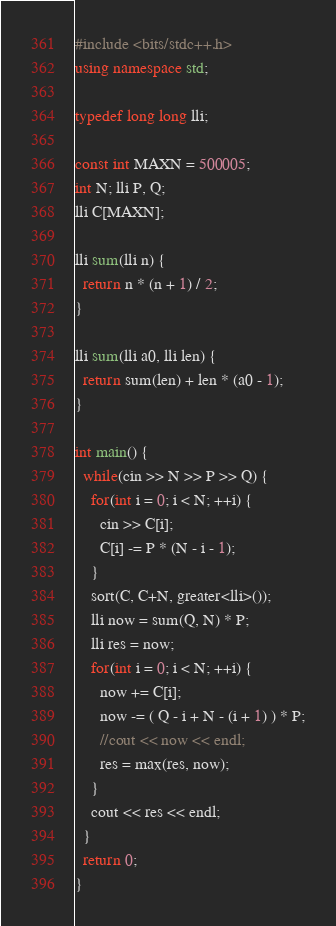Convert code to text. <code><loc_0><loc_0><loc_500><loc_500><_C++_>#include <bits/stdc++.h>
using namespace std;

typedef long long lli;

const int MAXN = 500005;
int N; lli P, Q;
lli C[MAXN];

lli sum(lli n) {
  return n * (n + 1) / 2;
}

lli sum(lli a0, lli len) {
  return sum(len) + len * (a0 - 1);
}

int main() {
  while(cin >> N >> P >> Q) {
    for(int i = 0; i < N; ++i) {
      cin >> C[i];
      C[i] -= P * (N - i - 1);
    }
    sort(C, C+N, greater<lli>());
    lli now = sum(Q, N) * P;
    lli res = now;
    for(int i = 0; i < N; ++i) {
      now += C[i];
      now -= ( Q - i + N - (i + 1) ) * P;
      //cout << now << endl;
      res = max(res, now);
    }
    cout << res << endl;
  }
  return 0;
}</code> 